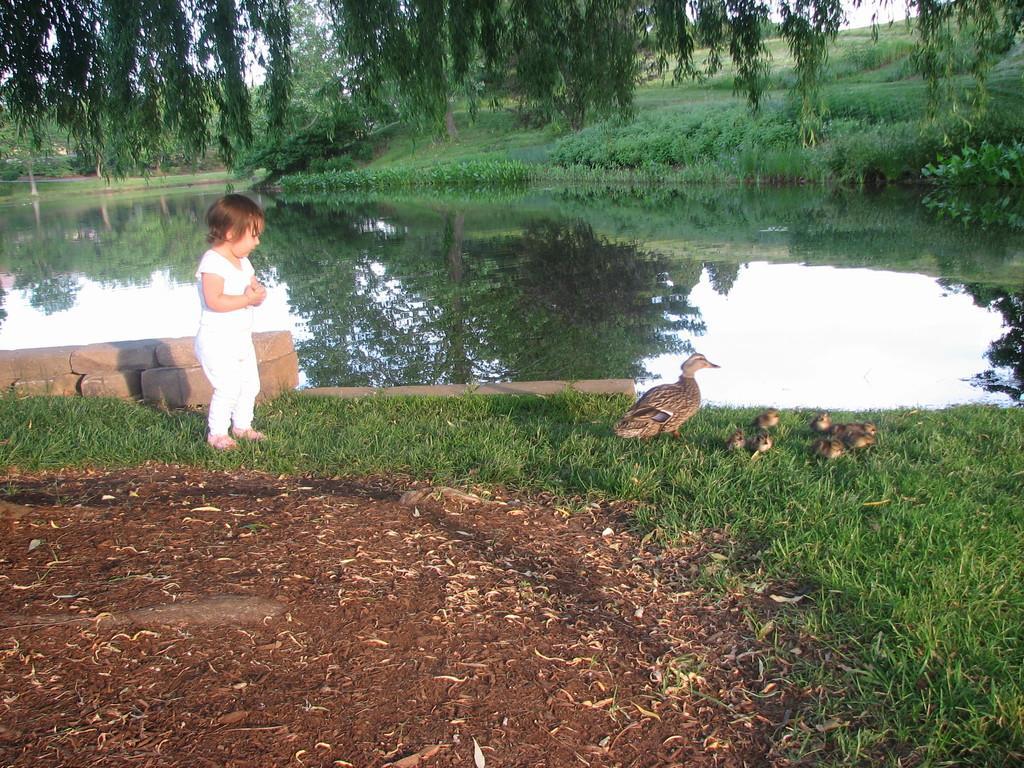Could you give a brief overview of what you see in this image? Here we can see a kid standing on the grass and there are birds. This is water. On the water we can see the reflection of trees. In the background we can see plants, trees, and sky. 